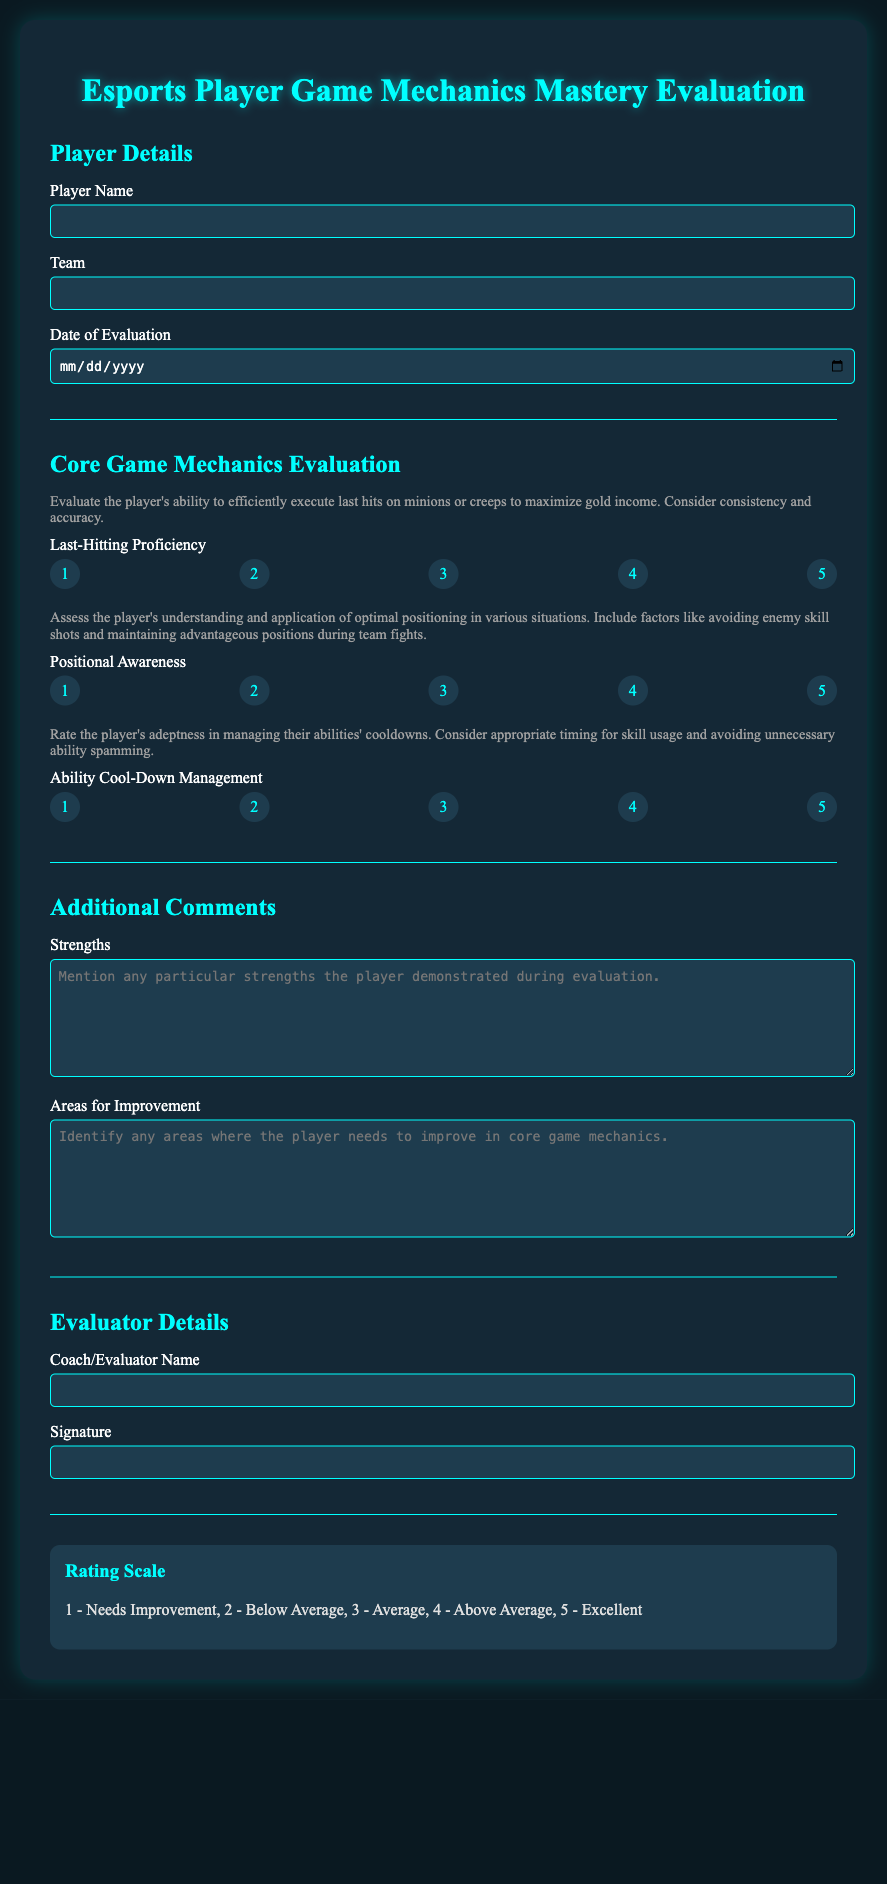What is the player's name? The player's name is recorded in the designated input field for the player name in the document.
Answer: Player Name What rating corresponds to "Needs Improvement"? The rating scale explains that "Needs Improvement" corresponds to a numeric score of 1.
Answer: 1 What is the highest rating a player can achieve for last-hitting proficiency? The document allows for a maximum rating of 5 for last-hitting proficiency.
Answer: 5 In what section can strengths be detailed? Strengths are detailed in the "Additional Comments" section of the document.
Answer: Additional Comments Who is meant to fill out the evaluator name? The evaluator name should be filled out by the coach or evaluator assessing the player's performance.
Answer: Coach/Evaluator Name What is the color of the section titles? The section titles in the document are colored in #00ffff (light cyan).
Answer: #00ffff How many core game mechanics are evaluated in this document? There are three core game mechanics evaluated: Last-Hitting Proficiency, Positional Awareness, and Ability Cool-Down Management.
Answer: Three What is the purpose of this evaluation form? The form is used to evaluate esports players' proficiency in core game mechanics to improve player performance.
Answer: Evaluate player performance What should be included in the areas for improvement? The areas for improvement should identify specific mechanics where the player needs to improve.
Answer: Identify areas for improvement 